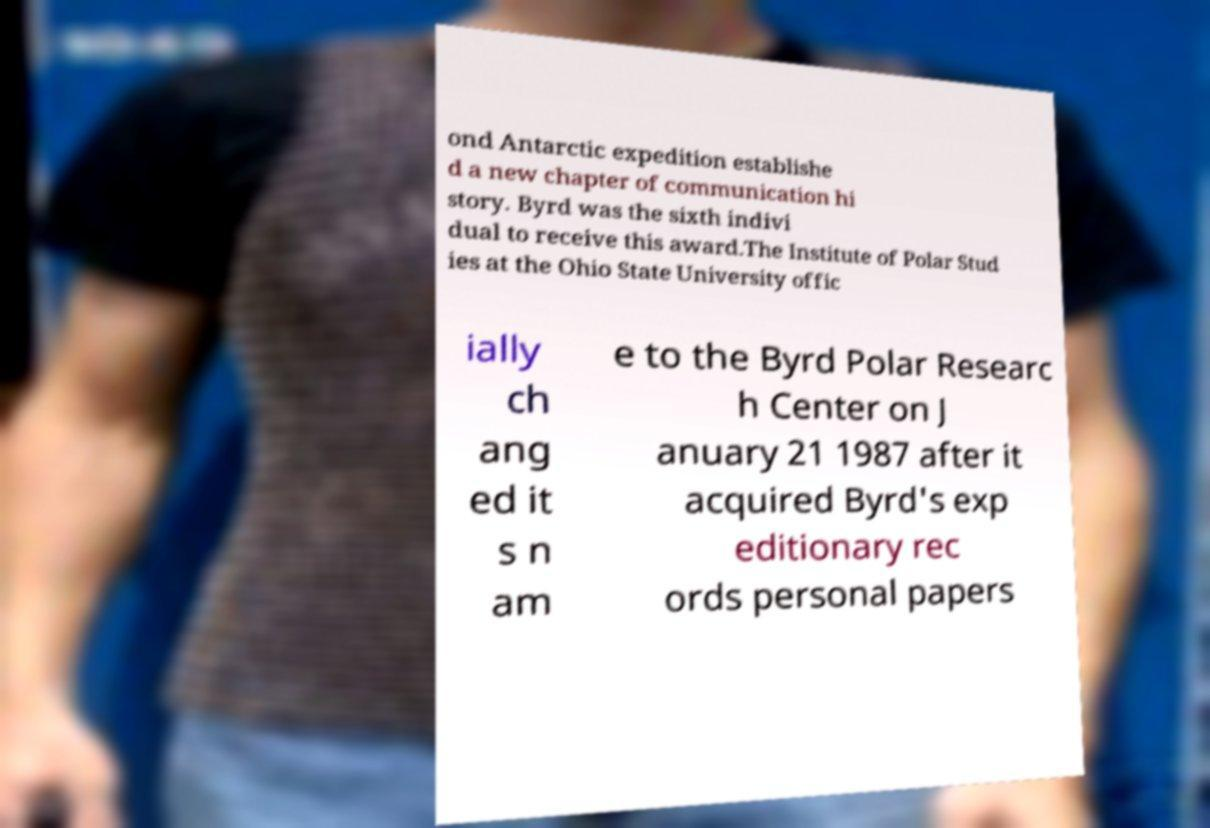There's text embedded in this image that I need extracted. Can you transcribe it verbatim? ond Antarctic expedition establishe d a new chapter of communication hi story. Byrd was the sixth indivi dual to receive this award.The Institute of Polar Stud ies at the Ohio State University offic ially ch ang ed it s n am e to the Byrd Polar Researc h Center on J anuary 21 1987 after it acquired Byrd's exp editionary rec ords personal papers 